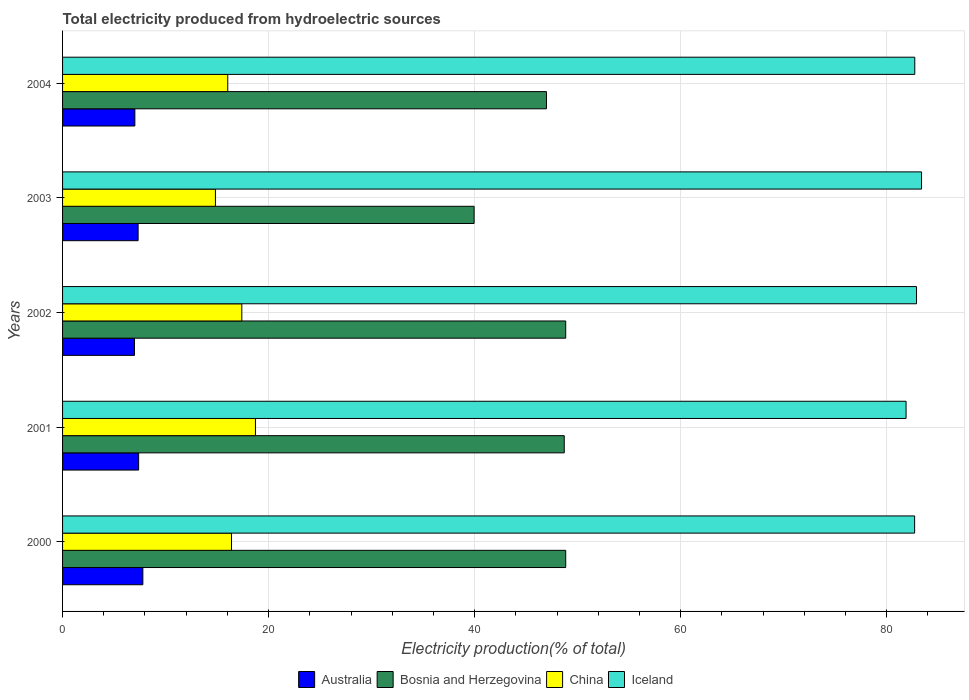How many different coloured bars are there?
Keep it short and to the point. 4. How many groups of bars are there?
Your response must be concise. 5. How many bars are there on the 4th tick from the top?
Your answer should be very brief. 4. In how many cases, is the number of bars for a given year not equal to the number of legend labels?
Keep it short and to the point. 0. What is the total electricity produced in Bosnia and Herzegovina in 2004?
Your answer should be compact. 46.98. Across all years, what is the maximum total electricity produced in Australia?
Make the answer very short. 7.8. Across all years, what is the minimum total electricity produced in Iceland?
Offer a terse response. 81.89. In which year was the total electricity produced in Bosnia and Herzegovina minimum?
Your response must be concise. 2003. What is the total total electricity produced in Iceland in the graph?
Provide a short and direct response. 413.63. What is the difference between the total electricity produced in Bosnia and Herzegovina in 2000 and that in 2003?
Ensure brevity in your answer.  8.89. What is the difference between the total electricity produced in China in 2000 and the total electricity produced in Bosnia and Herzegovina in 2003?
Provide a succinct answer. -23.55. What is the average total electricity produced in China per year?
Offer a terse response. 16.68. In the year 2000, what is the difference between the total electricity produced in Bosnia and Herzegovina and total electricity produced in China?
Offer a terse response. 32.45. What is the ratio of the total electricity produced in Iceland in 2002 to that in 2004?
Your answer should be compact. 1. Is the total electricity produced in Iceland in 2002 less than that in 2003?
Provide a succinct answer. Yes. What is the difference between the highest and the second highest total electricity produced in China?
Ensure brevity in your answer.  1.32. What is the difference between the highest and the lowest total electricity produced in Bosnia and Herzegovina?
Ensure brevity in your answer.  8.89. In how many years, is the total electricity produced in Bosnia and Herzegovina greater than the average total electricity produced in Bosnia and Herzegovina taken over all years?
Provide a succinct answer. 4. Is the sum of the total electricity produced in Iceland in 2001 and 2004 greater than the maximum total electricity produced in Bosnia and Herzegovina across all years?
Your answer should be compact. Yes. Is it the case that in every year, the sum of the total electricity produced in Iceland and total electricity produced in Australia is greater than the sum of total electricity produced in China and total electricity produced in Bosnia and Herzegovina?
Give a very brief answer. Yes. What does the 1st bar from the top in 2001 represents?
Offer a terse response. Iceland. What does the 3rd bar from the bottom in 2004 represents?
Offer a terse response. China. Is it the case that in every year, the sum of the total electricity produced in Australia and total electricity produced in Iceland is greater than the total electricity produced in Bosnia and Herzegovina?
Your answer should be compact. Yes. How many bars are there?
Your answer should be compact. 20. How many years are there in the graph?
Offer a very short reply. 5. What is the difference between two consecutive major ticks on the X-axis?
Give a very brief answer. 20. Are the values on the major ticks of X-axis written in scientific E-notation?
Make the answer very short. No. Does the graph contain any zero values?
Give a very brief answer. No. Does the graph contain grids?
Your answer should be compact. Yes. Where does the legend appear in the graph?
Provide a succinct answer. Bottom center. What is the title of the graph?
Make the answer very short. Total electricity produced from hydroelectric sources. Does "Tajikistan" appear as one of the legend labels in the graph?
Keep it short and to the point. No. What is the label or title of the X-axis?
Ensure brevity in your answer.  Electricity production(% of total). What is the label or title of the Y-axis?
Give a very brief answer. Years. What is the Electricity production(% of total) of Australia in 2000?
Give a very brief answer. 7.8. What is the Electricity production(% of total) in Bosnia and Herzegovina in 2000?
Your answer should be very brief. 48.84. What is the Electricity production(% of total) in China in 2000?
Ensure brevity in your answer.  16.4. What is the Electricity production(% of total) of Iceland in 2000?
Offer a very short reply. 82.72. What is the Electricity production(% of total) of Australia in 2001?
Your response must be concise. 7.39. What is the Electricity production(% of total) of Bosnia and Herzegovina in 2001?
Your response must be concise. 48.7. What is the Electricity production(% of total) in China in 2001?
Your answer should be very brief. 18.73. What is the Electricity production(% of total) in Iceland in 2001?
Offer a very short reply. 81.89. What is the Electricity production(% of total) of Australia in 2002?
Make the answer very short. 6.98. What is the Electricity production(% of total) of Bosnia and Herzegovina in 2002?
Your answer should be very brief. 48.85. What is the Electricity production(% of total) of China in 2002?
Give a very brief answer. 17.4. What is the Electricity production(% of total) of Iceland in 2002?
Your answer should be compact. 82.9. What is the Electricity production(% of total) in Australia in 2003?
Make the answer very short. 7.33. What is the Electricity production(% of total) of Bosnia and Herzegovina in 2003?
Your response must be concise. 39.95. What is the Electricity production(% of total) of China in 2003?
Offer a very short reply. 14.84. What is the Electricity production(% of total) of Iceland in 2003?
Provide a succinct answer. 83.39. What is the Electricity production(% of total) of Australia in 2004?
Make the answer very short. 7.02. What is the Electricity production(% of total) of Bosnia and Herzegovina in 2004?
Provide a short and direct response. 46.98. What is the Electricity production(% of total) in China in 2004?
Provide a short and direct response. 16.04. What is the Electricity production(% of total) of Iceland in 2004?
Your answer should be compact. 82.73. Across all years, what is the maximum Electricity production(% of total) of Australia?
Your answer should be compact. 7.8. Across all years, what is the maximum Electricity production(% of total) of Bosnia and Herzegovina?
Give a very brief answer. 48.85. Across all years, what is the maximum Electricity production(% of total) in China?
Your response must be concise. 18.73. Across all years, what is the maximum Electricity production(% of total) in Iceland?
Keep it short and to the point. 83.39. Across all years, what is the minimum Electricity production(% of total) in Australia?
Offer a very short reply. 6.98. Across all years, what is the minimum Electricity production(% of total) in Bosnia and Herzegovina?
Offer a terse response. 39.95. Across all years, what is the minimum Electricity production(% of total) of China?
Your response must be concise. 14.84. Across all years, what is the minimum Electricity production(% of total) of Iceland?
Make the answer very short. 81.89. What is the total Electricity production(% of total) in Australia in the graph?
Offer a terse response. 36.52. What is the total Electricity production(% of total) in Bosnia and Herzegovina in the graph?
Make the answer very short. 233.32. What is the total Electricity production(% of total) in China in the graph?
Offer a very short reply. 83.4. What is the total Electricity production(% of total) of Iceland in the graph?
Provide a succinct answer. 413.63. What is the difference between the Electricity production(% of total) in Australia in 2000 and that in 2001?
Ensure brevity in your answer.  0.41. What is the difference between the Electricity production(% of total) in Bosnia and Herzegovina in 2000 and that in 2001?
Your response must be concise. 0.14. What is the difference between the Electricity production(% of total) in China in 2000 and that in 2001?
Your response must be concise. -2.33. What is the difference between the Electricity production(% of total) of Iceland in 2000 and that in 2001?
Offer a very short reply. 0.83. What is the difference between the Electricity production(% of total) in Australia in 2000 and that in 2002?
Provide a succinct answer. 0.81. What is the difference between the Electricity production(% of total) of Bosnia and Herzegovina in 2000 and that in 2002?
Offer a terse response. -0. What is the difference between the Electricity production(% of total) in China in 2000 and that in 2002?
Your answer should be very brief. -1. What is the difference between the Electricity production(% of total) of Iceland in 2000 and that in 2002?
Your response must be concise. -0.18. What is the difference between the Electricity production(% of total) in Australia in 2000 and that in 2003?
Ensure brevity in your answer.  0.46. What is the difference between the Electricity production(% of total) of Bosnia and Herzegovina in 2000 and that in 2003?
Provide a succinct answer. 8.89. What is the difference between the Electricity production(% of total) in China in 2000 and that in 2003?
Your response must be concise. 1.56. What is the difference between the Electricity production(% of total) of Iceland in 2000 and that in 2003?
Your answer should be very brief. -0.67. What is the difference between the Electricity production(% of total) of Australia in 2000 and that in 2004?
Your response must be concise. 0.78. What is the difference between the Electricity production(% of total) of Bosnia and Herzegovina in 2000 and that in 2004?
Keep it short and to the point. 1.87. What is the difference between the Electricity production(% of total) in China in 2000 and that in 2004?
Make the answer very short. 0.36. What is the difference between the Electricity production(% of total) of Iceland in 2000 and that in 2004?
Offer a terse response. -0.01. What is the difference between the Electricity production(% of total) of Australia in 2001 and that in 2002?
Your answer should be compact. 0.4. What is the difference between the Electricity production(% of total) in Bosnia and Herzegovina in 2001 and that in 2002?
Your response must be concise. -0.14. What is the difference between the Electricity production(% of total) of China in 2001 and that in 2002?
Offer a terse response. 1.32. What is the difference between the Electricity production(% of total) of Iceland in 2001 and that in 2002?
Your response must be concise. -1.01. What is the difference between the Electricity production(% of total) in Australia in 2001 and that in 2003?
Ensure brevity in your answer.  0.05. What is the difference between the Electricity production(% of total) of Bosnia and Herzegovina in 2001 and that in 2003?
Offer a very short reply. 8.75. What is the difference between the Electricity production(% of total) of China in 2001 and that in 2003?
Your answer should be compact. 3.89. What is the difference between the Electricity production(% of total) in Iceland in 2001 and that in 2003?
Provide a succinct answer. -1.5. What is the difference between the Electricity production(% of total) in Australia in 2001 and that in 2004?
Ensure brevity in your answer.  0.37. What is the difference between the Electricity production(% of total) of Bosnia and Herzegovina in 2001 and that in 2004?
Offer a terse response. 1.73. What is the difference between the Electricity production(% of total) of China in 2001 and that in 2004?
Provide a succinct answer. 2.69. What is the difference between the Electricity production(% of total) of Iceland in 2001 and that in 2004?
Your answer should be compact. -0.84. What is the difference between the Electricity production(% of total) in Australia in 2002 and that in 2003?
Offer a very short reply. -0.35. What is the difference between the Electricity production(% of total) in Bosnia and Herzegovina in 2002 and that in 2003?
Give a very brief answer. 8.89. What is the difference between the Electricity production(% of total) of China in 2002 and that in 2003?
Your answer should be very brief. 2.56. What is the difference between the Electricity production(% of total) in Iceland in 2002 and that in 2003?
Provide a short and direct response. -0.49. What is the difference between the Electricity production(% of total) of Australia in 2002 and that in 2004?
Keep it short and to the point. -0.04. What is the difference between the Electricity production(% of total) of Bosnia and Herzegovina in 2002 and that in 2004?
Keep it short and to the point. 1.87. What is the difference between the Electricity production(% of total) in China in 2002 and that in 2004?
Offer a terse response. 1.37. What is the difference between the Electricity production(% of total) of Iceland in 2002 and that in 2004?
Provide a succinct answer. 0.17. What is the difference between the Electricity production(% of total) in Australia in 2003 and that in 2004?
Give a very brief answer. 0.32. What is the difference between the Electricity production(% of total) in Bosnia and Herzegovina in 2003 and that in 2004?
Offer a terse response. -7.02. What is the difference between the Electricity production(% of total) of China in 2003 and that in 2004?
Make the answer very short. -1.2. What is the difference between the Electricity production(% of total) in Iceland in 2003 and that in 2004?
Provide a short and direct response. 0.66. What is the difference between the Electricity production(% of total) in Australia in 2000 and the Electricity production(% of total) in Bosnia and Herzegovina in 2001?
Offer a terse response. -40.91. What is the difference between the Electricity production(% of total) of Australia in 2000 and the Electricity production(% of total) of China in 2001?
Provide a succinct answer. -10.93. What is the difference between the Electricity production(% of total) in Australia in 2000 and the Electricity production(% of total) in Iceland in 2001?
Provide a succinct answer. -74.09. What is the difference between the Electricity production(% of total) of Bosnia and Herzegovina in 2000 and the Electricity production(% of total) of China in 2001?
Keep it short and to the point. 30.12. What is the difference between the Electricity production(% of total) of Bosnia and Herzegovina in 2000 and the Electricity production(% of total) of Iceland in 2001?
Provide a succinct answer. -33.04. What is the difference between the Electricity production(% of total) of China in 2000 and the Electricity production(% of total) of Iceland in 2001?
Your response must be concise. -65.49. What is the difference between the Electricity production(% of total) in Australia in 2000 and the Electricity production(% of total) in Bosnia and Herzegovina in 2002?
Offer a very short reply. -41.05. What is the difference between the Electricity production(% of total) in Australia in 2000 and the Electricity production(% of total) in China in 2002?
Make the answer very short. -9.61. What is the difference between the Electricity production(% of total) in Australia in 2000 and the Electricity production(% of total) in Iceland in 2002?
Provide a succinct answer. -75.11. What is the difference between the Electricity production(% of total) of Bosnia and Herzegovina in 2000 and the Electricity production(% of total) of China in 2002?
Your answer should be very brief. 31.44. What is the difference between the Electricity production(% of total) of Bosnia and Herzegovina in 2000 and the Electricity production(% of total) of Iceland in 2002?
Ensure brevity in your answer.  -34.06. What is the difference between the Electricity production(% of total) of China in 2000 and the Electricity production(% of total) of Iceland in 2002?
Your response must be concise. -66.5. What is the difference between the Electricity production(% of total) of Australia in 2000 and the Electricity production(% of total) of Bosnia and Herzegovina in 2003?
Your answer should be compact. -32.16. What is the difference between the Electricity production(% of total) in Australia in 2000 and the Electricity production(% of total) in China in 2003?
Give a very brief answer. -7.04. What is the difference between the Electricity production(% of total) in Australia in 2000 and the Electricity production(% of total) in Iceland in 2003?
Keep it short and to the point. -75.59. What is the difference between the Electricity production(% of total) in Bosnia and Herzegovina in 2000 and the Electricity production(% of total) in China in 2003?
Offer a terse response. 34.01. What is the difference between the Electricity production(% of total) in Bosnia and Herzegovina in 2000 and the Electricity production(% of total) in Iceland in 2003?
Keep it short and to the point. -34.54. What is the difference between the Electricity production(% of total) in China in 2000 and the Electricity production(% of total) in Iceland in 2003?
Give a very brief answer. -66.99. What is the difference between the Electricity production(% of total) in Australia in 2000 and the Electricity production(% of total) in Bosnia and Herzegovina in 2004?
Give a very brief answer. -39.18. What is the difference between the Electricity production(% of total) in Australia in 2000 and the Electricity production(% of total) in China in 2004?
Provide a succinct answer. -8.24. What is the difference between the Electricity production(% of total) of Australia in 2000 and the Electricity production(% of total) of Iceland in 2004?
Your answer should be very brief. -74.94. What is the difference between the Electricity production(% of total) in Bosnia and Herzegovina in 2000 and the Electricity production(% of total) in China in 2004?
Ensure brevity in your answer.  32.81. What is the difference between the Electricity production(% of total) in Bosnia and Herzegovina in 2000 and the Electricity production(% of total) in Iceland in 2004?
Provide a succinct answer. -33.89. What is the difference between the Electricity production(% of total) in China in 2000 and the Electricity production(% of total) in Iceland in 2004?
Make the answer very short. -66.33. What is the difference between the Electricity production(% of total) in Australia in 2001 and the Electricity production(% of total) in Bosnia and Herzegovina in 2002?
Provide a short and direct response. -41.46. What is the difference between the Electricity production(% of total) of Australia in 2001 and the Electricity production(% of total) of China in 2002?
Provide a short and direct response. -10.02. What is the difference between the Electricity production(% of total) in Australia in 2001 and the Electricity production(% of total) in Iceland in 2002?
Provide a short and direct response. -75.52. What is the difference between the Electricity production(% of total) in Bosnia and Herzegovina in 2001 and the Electricity production(% of total) in China in 2002?
Your response must be concise. 31.3. What is the difference between the Electricity production(% of total) of Bosnia and Herzegovina in 2001 and the Electricity production(% of total) of Iceland in 2002?
Your answer should be compact. -34.2. What is the difference between the Electricity production(% of total) of China in 2001 and the Electricity production(% of total) of Iceland in 2002?
Offer a terse response. -64.18. What is the difference between the Electricity production(% of total) in Australia in 2001 and the Electricity production(% of total) in Bosnia and Herzegovina in 2003?
Your answer should be compact. -32.57. What is the difference between the Electricity production(% of total) of Australia in 2001 and the Electricity production(% of total) of China in 2003?
Your answer should be compact. -7.45. What is the difference between the Electricity production(% of total) of Australia in 2001 and the Electricity production(% of total) of Iceland in 2003?
Your answer should be very brief. -76. What is the difference between the Electricity production(% of total) of Bosnia and Herzegovina in 2001 and the Electricity production(% of total) of China in 2003?
Ensure brevity in your answer.  33.86. What is the difference between the Electricity production(% of total) in Bosnia and Herzegovina in 2001 and the Electricity production(% of total) in Iceland in 2003?
Keep it short and to the point. -34.69. What is the difference between the Electricity production(% of total) of China in 2001 and the Electricity production(% of total) of Iceland in 2003?
Your answer should be very brief. -64.66. What is the difference between the Electricity production(% of total) of Australia in 2001 and the Electricity production(% of total) of Bosnia and Herzegovina in 2004?
Your answer should be very brief. -39.59. What is the difference between the Electricity production(% of total) of Australia in 2001 and the Electricity production(% of total) of China in 2004?
Give a very brief answer. -8.65. What is the difference between the Electricity production(% of total) in Australia in 2001 and the Electricity production(% of total) in Iceland in 2004?
Your response must be concise. -75.35. What is the difference between the Electricity production(% of total) of Bosnia and Herzegovina in 2001 and the Electricity production(% of total) of China in 2004?
Your response must be concise. 32.67. What is the difference between the Electricity production(% of total) of Bosnia and Herzegovina in 2001 and the Electricity production(% of total) of Iceland in 2004?
Offer a very short reply. -34.03. What is the difference between the Electricity production(% of total) of China in 2001 and the Electricity production(% of total) of Iceland in 2004?
Offer a terse response. -64.01. What is the difference between the Electricity production(% of total) of Australia in 2002 and the Electricity production(% of total) of Bosnia and Herzegovina in 2003?
Offer a very short reply. -32.97. What is the difference between the Electricity production(% of total) of Australia in 2002 and the Electricity production(% of total) of China in 2003?
Give a very brief answer. -7.86. What is the difference between the Electricity production(% of total) of Australia in 2002 and the Electricity production(% of total) of Iceland in 2003?
Make the answer very short. -76.41. What is the difference between the Electricity production(% of total) in Bosnia and Herzegovina in 2002 and the Electricity production(% of total) in China in 2003?
Your response must be concise. 34.01. What is the difference between the Electricity production(% of total) in Bosnia and Herzegovina in 2002 and the Electricity production(% of total) in Iceland in 2003?
Provide a succinct answer. -34.54. What is the difference between the Electricity production(% of total) of China in 2002 and the Electricity production(% of total) of Iceland in 2003?
Keep it short and to the point. -65.99. What is the difference between the Electricity production(% of total) in Australia in 2002 and the Electricity production(% of total) in Bosnia and Herzegovina in 2004?
Provide a succinct answer. -39.99. What is the difference between the Electricity production(% of total) of Australia in 2002 and the Electricity production(% of total) of China in 2004?
Make the answer very short. -9.05. What is the difference between the Electricity production(% of total) of Australia in 2002 and the Electricity production(% of total) of Iceland in 2004?
Provide a succinct answer. -75.75. What is the difference between the Electricity production(% of total) in Bosnia and Herzegovina in 2002 and the Electricity production(% of total) in China in 2004?
Your response must be concise. 32.81. What is the difference between the Electricity production(% of total) of Bosnia and Herzegovina in 2002 and the Electricity production(% of total) of Iceland in 2004?
Your response must be concise. -33.89. What is the difference between the Electricity production(% of total) in China in 2002 and the Electricity production(% of total) in Iceland in 2004?
Your response must be concise. -65.33. What is the difference between the Electricity production(% of total) in Australia in 2003 and the Electricity production(% of total) in Bosnia and Herzegovina in 2004?
Give a very brief answer. -39.64. What is the difference between the Electricity production(% of total) in Australia in 2003 and the Electricity production(% of total) in China in 2004?
Offer a very short reply. -8.7. What is the difference between the Electricity production(% of total) in Australia in 2003 and the Electricity production(% of total) in Iceland in 2004?
Offer a very short reply. -75.4. What is the difference between the Electricity production(% of total) in Bosnia and Herzegovina in 2003 and the Electricity production(% of total) in China in 2004?
Your answer should be compact. 23.92. What is the difference between the Electricity production(% of total) of Bosnia and Herzegovina in 2003 and the Electricity production(% of total) of Iceland in 2004?
Provide a succinct answer. -42.78. What is the difference between the Electricity production(% of total) in China in 2003 and the Electricity production(% of total) in Iceland in 2004?
Keep it short and to the point. -67.89. What is the average Electricity production(% of total) of Australia per year?
Make the answer very short. 7.3. What is the average Electricity production(% of total) in Bosnia and Herzegovina per year?
Keep it short and to the point. 46.66. What is the average Electricity production(% of total) in China per year?
Offer a terse response. 16.68. What is the average Electricity production(% of total) of Iceland per year?
Your response must be concise. 82.73. In the year 2000, what is the difference between the Electricity production(% of total) of Australia and Electricity production(% of total) of Bosnia and Herzegovina?
Your answer should be compact. -41.05. In the year 2000, what is the difference between the Electricity production(% of total) in Australia and Electricity production(% of total) in China?
Provide a succinct answer. -8.6. In the year 2000, what is the difference between the Electricity production(% of total) of Australia and Electricity production(% of total) of Iceland?
Offer a very short reply. -74.92. In the year 2000, what is the difference between the Electricity production(% of total) of Bosnia and Herzegovina and Electricity production(% of total) of China?
Your response must be concise. 32.45. In the year 2000, what is the difference between the Electricity production(% of total) of Bosnia and Herzegovina and Electricity production(% of total) of Iceland?
Your answer should be very brief. -33.87. In the year 2000, what is the difference between the Electricity production(% of total) in China and Electricity production(% of total) in Iceland?
Ensure brevity in your answer.  -66.32. In the year 2001, what is the difference between the Electricity production(% of total) in Australia and Electricity production(% of total) in Bosnia and Herzegovina?
Provide a short and direct response. -41.32. In the year 2001, what is the difference between the Electricity production(% of total) of Australia and Electricity production(% of total) of China?
Offer a terse response. -11.34. In the year 2001, what is the difference between the Electricity production(% of total) of Australia and Electricity production(% of total) of Iceland?
Offer a terse response. -74.5. In the year 2001, what is the difference between the Electricity production(% of total) of Bosnia and Herzegovina and Electricity production(% of total) of China?
Keep it short and to the point. 29.98. In the year 2001, what is the difference between the Electricity production(% of total) of Bosnia and Herzegovina and Electricity production(% of total) of Iceland?
Offer a very short reply. -33.18. In the year 2001, what is the difference between the Electricity production(% of total) in China and Electricity production(% of total) in Iceland?
Give a very brief answer. -63.16. In the year 2002, what is the difference between the Electricity production(% of total) of Australia and Electricity production(% of total) of Bosnia and Herzegovina?
Make the answer very short. -41.86. In the year 2002, what is the difference between the Electricity production(% of total) in Australia and Electricity production(% of total) in China?
Your answer should be very brief. -10.42. In the year 2002, what is the difference between the Electricity production(% of total) of Australia and Electricity production(% of total) of Iceland?
Make the answer very short. -75.92. In the year 2002, what is the difference between the Electricity production(% of total) in Bosnia and Herzegovina and Electricity production(% of total) in China?
Offer a very short reply. 31.44. In the year 2002, what is the difference between the Electricity production(% of total) of Bosnia and Herzegovina and Electricity production(% of total) of Iceland?
Give a very brief answer. -34.06. In the year 2002, what is the difference between the Electricity production(% of total) of China and Electricity production(% of total) of Iceland?
Your answer should be compact. -65.5. In the year 2003, what is the difference between the Electricity production(% of total) in Australia and Electricity production(% of total) in Bosnia and Herzegovina?
Keep it short and to the point. -32.62. In the year 2003, what is the difference between the Electricity production(% of total) of Australia and Electricity production(% of total) of China?
Your response must be concise. -7.51. In the year 2003, what is the difference between the Electricity production(% of total) in Australia and Electricity production(% of total) in Iceland?
Offer a very short reply. -76.05. In the year 2003, what is the difference between the Electricity production(% of total) in Bosnia and Herzegovina and Electricity production(% of total) in China?
Your answer should be compact. 25.11. In the year 2003, what is the difference between the Electricity production(% of total) in Bosnia and Herzegovina and Electricity production(% of total) in Iceland?
Your answer should be compact. -43.44. In the year 2003, what is the difference between the Electricity production(% of total) of China and Electricity production(% of total) of Iceland?
Provide a short and direct response. -68.55. In the year 2004, what is the difference between the Electricity production(% of total) in Australia and Electricity production(% of total) in Bosnia and Herzegovina?
Ensure brevity in your answer.  -39.96. In the year 2004, what is the difference between the Electricity production(% of total) in Australia and Electricity production(% of total) in China?
Give a very brief answer. -9.02. In the year 2004, what is the difference between the Electricity production(% of total) of Australia and Electricity production(% of total) of Iceland?
Give a very brief answer. -75.71. In the year 2004, what is the difference between the Electricity production(% of total) of Bosnia and Herzegovina and Electricity production(% of total) of China?
Offer a terse response. 30.94. In the year 2004, what is the difference between the Electricity production(% of total) of Bosnia and Herzegovina and Electricity production(% of total) of Iceland?
Provide a short and direct response. -35.76. In the year 2004, what is the difference between the Electricity production(% of total) in China and Electricity production(% of total) in Iceland?
Make the answer very short. -66.7. What is the ratio of the Electricity production(% of total) of Australia in 2000 to that in 2001?
Offer a very short reply. 1.06. What is the ratio of the Electricity production(% of total) of China in 2000 to that in 2001?
Offer a terse response. 0.88. What is the ratio of the Electricity production(% of total) in Iceland in 2000 to that in 2001?
Provide a succinct answer. 1.01. What is the ratio of the Electricity production(% of total) in Australia in 2000 to that in 2002?
Your answer should be very brief. 1.12. What is the ratio of the Electricity production(% of total) in China in 2000 to that in 2002?
Make the answer very short. 0.94. What is the ratio of the Electricity production(% of total) in Australia in 2000 to that in 2003?
Ensure brevity in your answer.  1.06. What is the ratio of the Electricity production(% of total) of Bosnia and Herzegovina in 2000 to that in 2003?
Offer a very short reply. 1.22. What is the ratio of the Electricity production(% of total) of China in 2000 to that in 2003?
Your answer should be very brief. 1.11. What is the ratio of the Electricity production(% of total) of Iceland in 2000 to that in 2003?
Ensure brevity in your answer.  0.99. What is the ratio of the Electricity production(% of total) in Australia in 2000 to that in 2004?
Provide a succinct answer. 1.11. What is the ratio of the Electricity production(% of total) of Bosnia and Herzegovina in 2000 to that in 2004?
Offer a very short reply. 1.04. What is the ratio of the Electricity production(% of total) of China in 2000 to that in 2004?
Your response must be concise. 1.02. What is the ratio of the Electricity production(% of total) in Australia in 2001 to that in 2002?
Offer a very short reply. 1.06. What is the ratio of the Electricity production(% of total) in China in 2001 to that in 2002?
Make the answer very short. 1.08. What is the ratio of the Electricity production(% of total) in Australia in 2001 to that in 2003?
Give a very brief answer. 1.01. What is the ratio of the Electricity production(% of total) in Bosnia and Herzegovina in 2001 to that in 2003?
Offer a very short reply. 1.22. What is the ratio of the Electricity production(% of total) of China in 2001 to that in 2003?
Your answer should be compact. 1.26. What is the ratio of the Electricity production(% of total) in Iceland in 2001 to that in 2003?
Make the answer very short. 0.98. What is the ratio of the Electricity production(% of total) in Australia in 2001 to that in 2004?
Provide a short and direct response. 1.05. What is the ratio of the Electricity production(% of total) in Bosnia and Herzegovina in 2001 to that in 2004?
Offer a very short reply. 1.04. What is the ratio of the Electricity production(% of total) of China in 2001 to that in 2004?
Offer a very short reply. 1.17. What is the ratio of the Electricity production(% of total) of Australia in 2002 to that in 2003?
Your answer should be compact. 0.95. What is the ratio of the Electricity production(% of total) in Bosnia and Herzegovina in 2002 to that in 2003?
Your answer should be very brief. 1.22. What is the ratio of the Electricity production(% of total) in China in 2002 to that in 2003?
Provide a short and direct response. 1.17. What is the ratio of the Electricity production(% of total) in Bosnia and Herzegovina in 2002 to that in 2004?
Offer a very short reply. 1.04. What is the ratio of the Electricity production(% of total) in China in 2002 to that in 2004?
Provide a short and direct response. 1.09. What is the ratio of the Electricity production(% of total) of Iceland in 2002 to that in 2004?
Provide a short and direct response. 1. What is the ratio of the Electricity production(% of total) of Australia in 2003 to that in 2004?
Keep it short and to the point. 1.04. What is the ratio of the Electricity production(% of total) of Bosnia and Herzegovina in 2003 to that in 2004?
Keep it short and to the point. 0.85. What is the ratio of the Electricity production(% of total) of China in 2003 to that in 2004?
Offer a terse response. 0.93. What is the ratio of the Electricity production(% of total) in Iceland in 2003 to that in 2004?
Offer a terse response. 1.01. What is the difference between the highest and the second highest Electricity production(% of total) in Australia?
Your answer should be very brief. 0.41. What is the difference between the highest and the second highest Electricity production(% of total) of Bosnia and Herzegovina?
Ensure brevity in your answer.  0. What is the difference between the highest and the second highest Electricity production(% of total) of China?
Provide a short and direct response. 1.32. What is the difference between the highest and the second highest Electricity production(% of total) of Iceland?
Make the answer very short. 0.49. What is the difference between the highest and the lowest Electricity production(% of total) in Australia?
Give a very brief answer. 0.81. What is the difference between the highest and the lowest Electricity production(% of total) of Bosnia and Herzegovina?
Your answer should be very brief. 8.89. What is the difference between the highest and the lowest Electricity production(% of total) of China?
Provide a short and direct response. 3.89. What is the difference between the highest and the lowest Electricity production(% of total) in Iceland?
Your answer should be very brief. 1.5. 